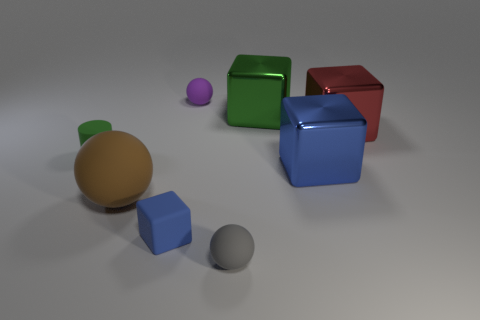What number of small green cylinders are behind the tiny ball in front of the small cylinder?
Your response must be concise. 1. There is a small green thing that is the same material as the big ball; what shape is it?
Offer a terse response. Cylinder. How many yellow objects are shiny blocks or big spheres?
Offer a very short reply. 0. Are there any small cylinders on the right side of the green thing to the left of the ball in front of the brown thing?
Make the answer very short. No. Are there fewer purple balls than rubber balls?
Provide a succinct answer. Yes. There is a blue object that is to the left of the tiny gray object; does it have the same shape as the large green metal object?
Ensure brevity in your answer.  Yes. Is there a green shiny cube?
Provide a succinct answer. Yes. The small rubber sphere in front of the tiny matte ball that is behind the sphere in front of the small blue rubber block is what color?
Keep it short and to the point. Gray. Is the number of tiny gray rubber balls on the right side of the tiny gray rubber sphere the same as the number of big spheres behind the blue shiny block?
Provide a short and direct response. Yes. There is a purple rubber thing that is the same size as the green rubber thing; what shape is it?
Your answer should be very brief. Sphere. 